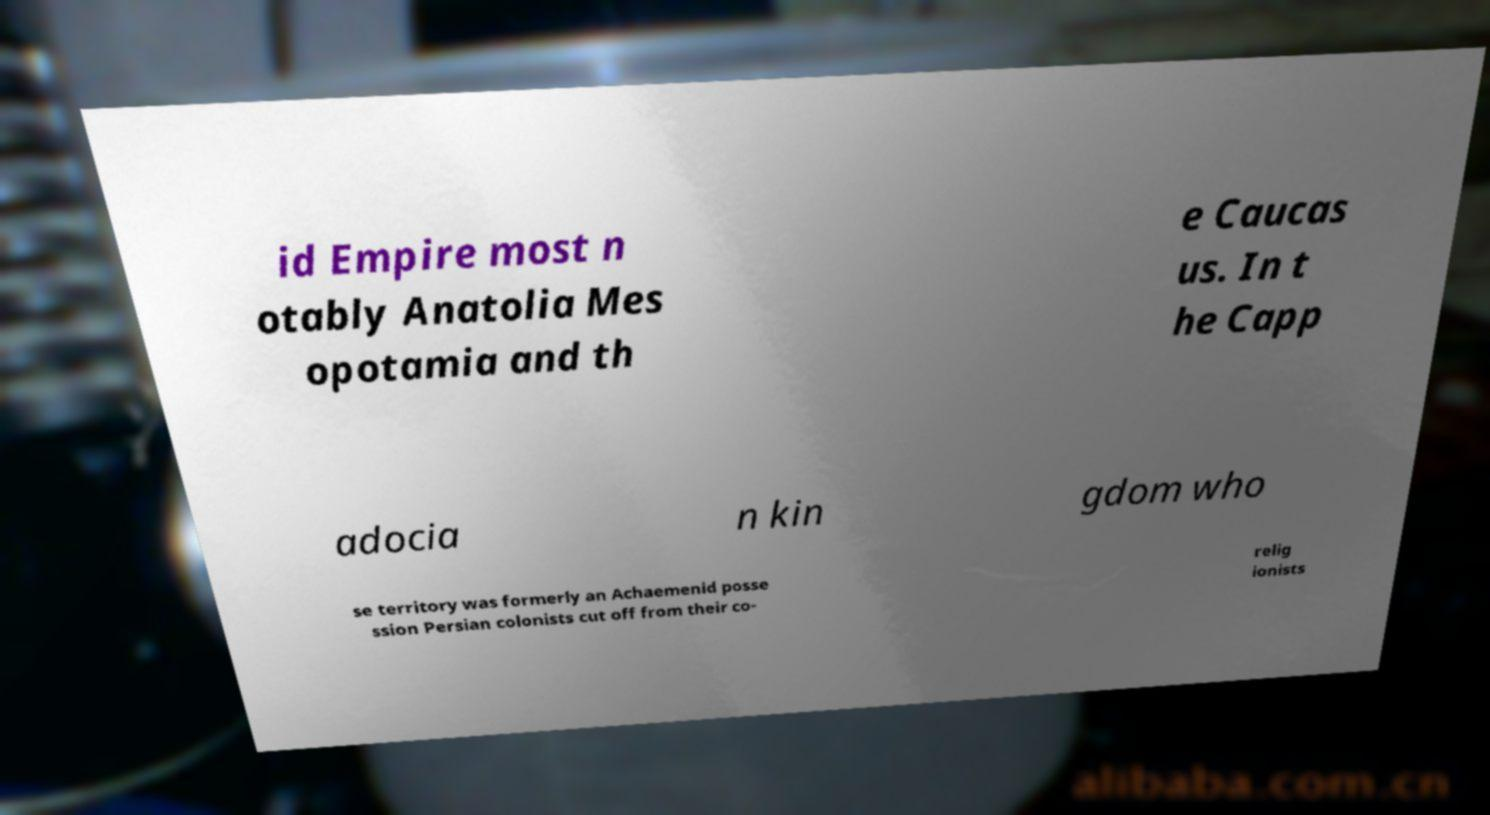Can you read and provide the text displayed in the image?This photo seems to have some interesting text. Can you extract and type it out for me? id Empire most n otably Anatolia Mes opotamia and th e Caucas us. In t he Capp adocia n kin gdom who se territory was formerly an Achaemenid posse ssion Persian colonists cut off from their co- relig ionists 